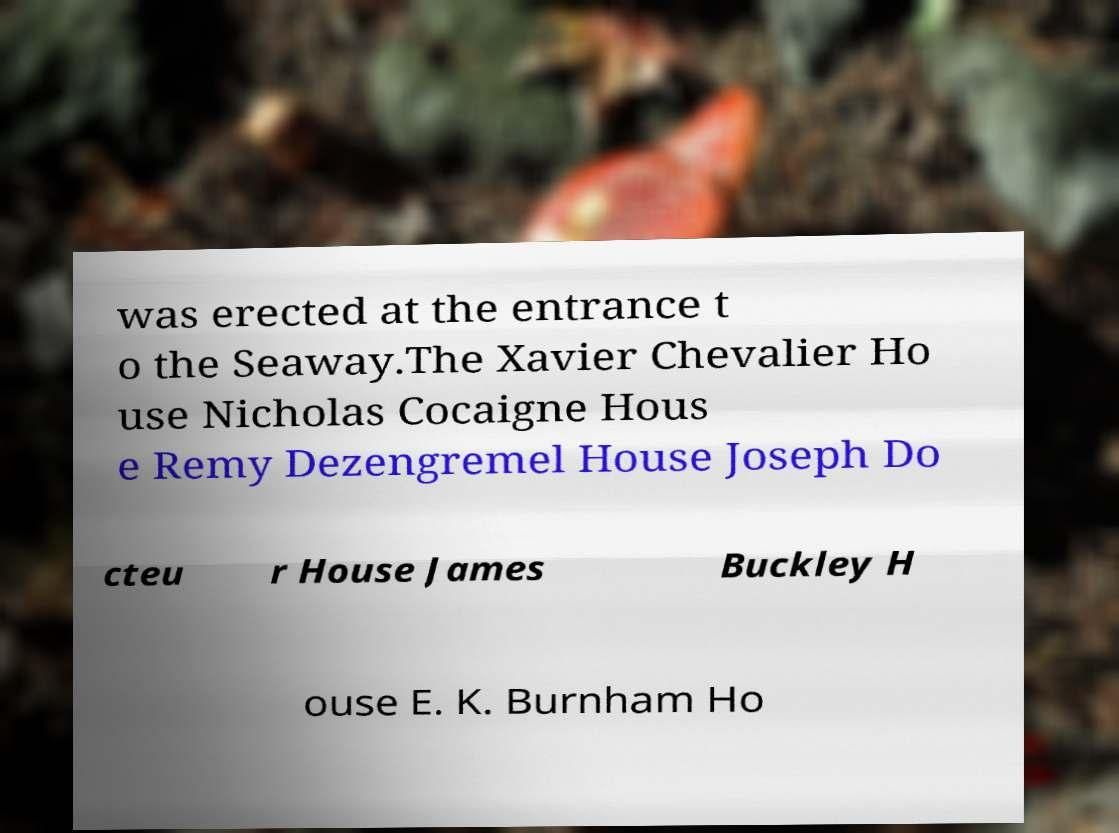Could you assist in decoding the text presented in this image and type it out clearly? was erected at the entrance t o the Seaway.The Xavier Chevalier Ho use Nicholas Cocaigne Hous e Remy Dezengremel House Joseph Do cteu r House James Buckley H ouse E. K. Burnham Ho 